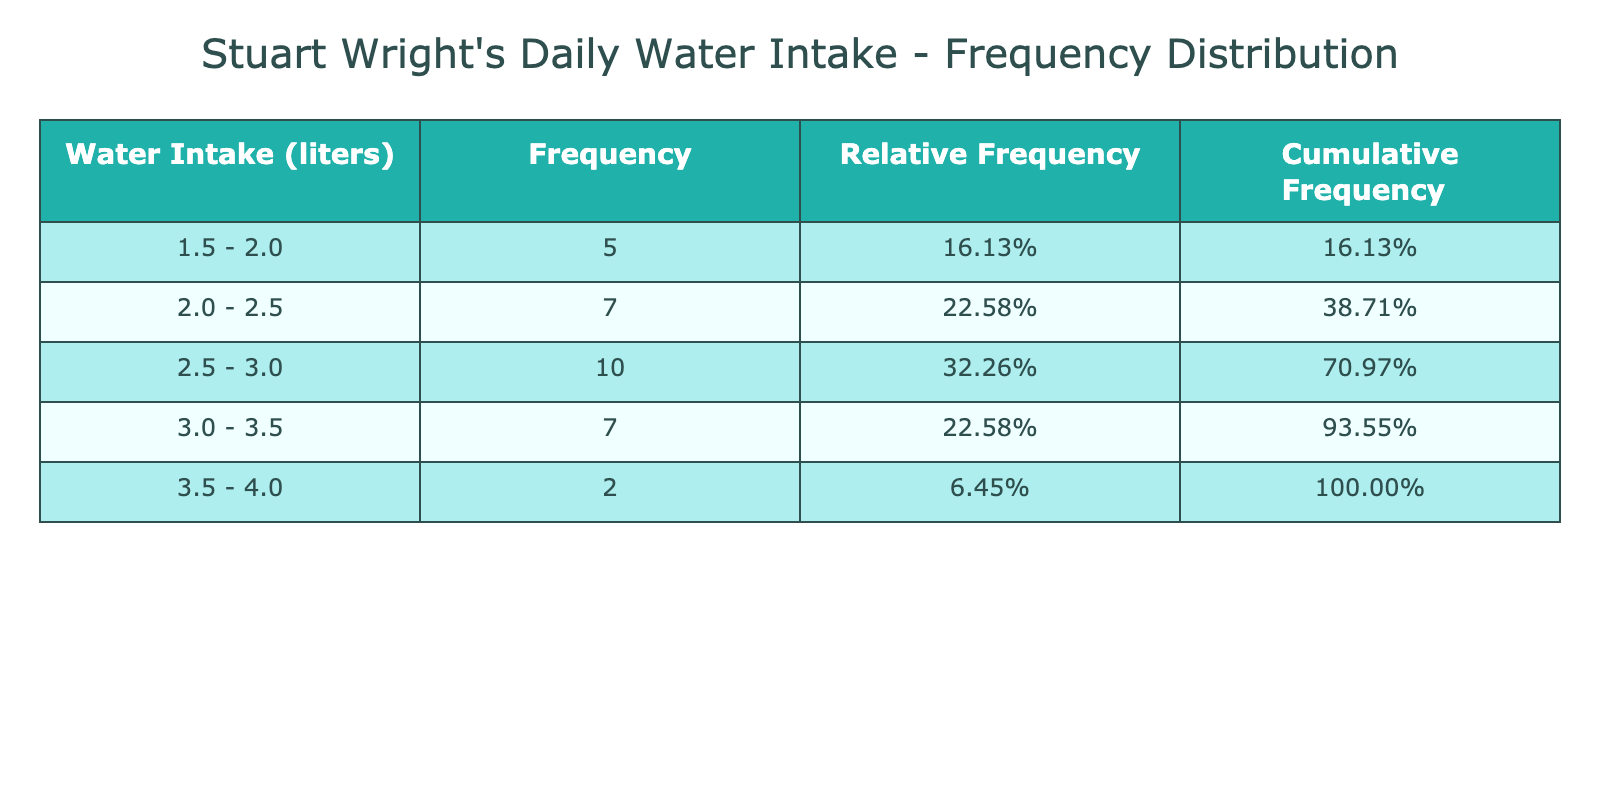What is the frequency of days with a water intake of 2.5 liters? From the frequency distribution table, we can see the bin for 2.5 - 3.0 liters has a frequency which indicates the number of days with a water intake between those values. Checking this bin shows that the frequency is 4.
Answer: 4 How many days had a water intake of 3.0 liters or more? We can check the bins that start from 3.0 liters and above. In the frequency distribution, the bins for 3.0 - 3.5 liters, 3.5 - 4.0 liters indicate the counts which adds up to 8 days overall.
Answer: 8 What is the relative frequency of days with a water intake of 1.7 liters? The table shows that 1.7 liters falls into the bin labeled 1.5 - 2.0 liters. The frequency for this bin is 2, and since the total days recorded are 31, we calculate the relative frequency as 2/31 ≈ 0.065 or 6.45%.
Answer: 6.45% Is there a day in the month when water intake was exactly 4.0 liters? By looking at the frequency distribution, we see that the 4.0 - 4.5 liters bin contains a frequency of 1 which indicates that there was one day with a water intake of exactly 4.0 liters. Hence, the answer is yes.
Answer: Yes What is the cumulative frequency for the water intake range of 2.5 - 3.0 liters? We need to sum the frequencies of all bins up to the 2.5 - 3.0 liters bin. Looking at the table, the frequencies of the preceding bins (1.5 - 2.0 and 2.0 - 2.5) and the current bin add up to 8 days (2 + 4 + 2).
Answer: 8 What was the average water intake for the month? To find the average, we sum all the water intake readings and divide by the number of days (31). The total intake sums up to 79.5 liters, so the average is 79.5/31 ≈ 2.56 liters.
Answer: 2.56 How many days had a water intake less than 2.5 liters? The bins below 2.5 liters are 1.5 - 2.0 and 2.0 - 2.5. The frequencies in these bins add up to 2 (for 1.5 - 2.0) and 4 (for 2.0 - 2.5), which totals 6 days with an intake below 2.5 liters.
Answer: 6 Is it true that more days had an intake of at least 3.5 liters compared to those with less than 2.0 liters? Looking at the bins, we find that the bins for 3.5 - 4.0 record a frequency of 6 days (3.5 and 4.0), while the 1.5 - 2.0 bin has 2 days, confirming that more days indeed had an intake of at least 3.5 liters. Therefore, the statement is true.
Answer: True 